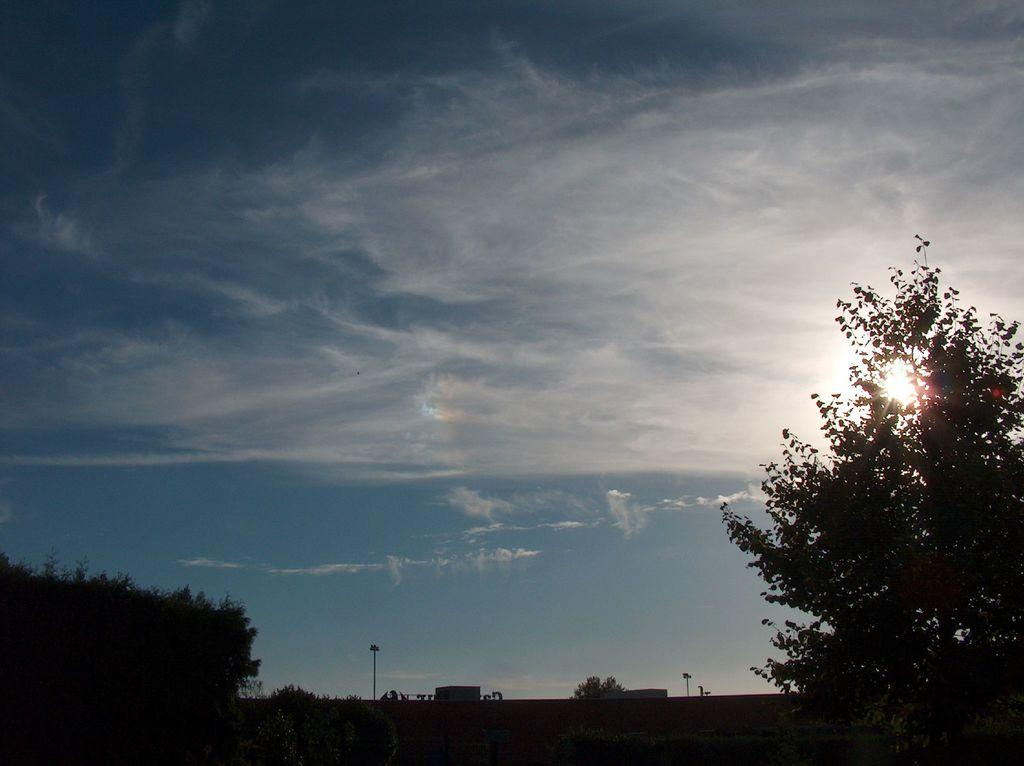What type of vegetation can be seen in the image? There are trees in the image. What is located behind the trees? There is a building behind the trees. What is visible at the top of the image? The sky is visible at the top of the image. What can be seen in the sky? There are clouds in the sky. What structures are present at the bottom of the image? There are poles with lights in the bottom of the image. What type of substance is being taught in the building behind the trees? There is no indication in the image of any educational activities taking place in the building, so it cannot be determined what type of substance is being taught. What is the interest of the clouds in the sky? Clouds do not have interests, as they are inanimate objects. 